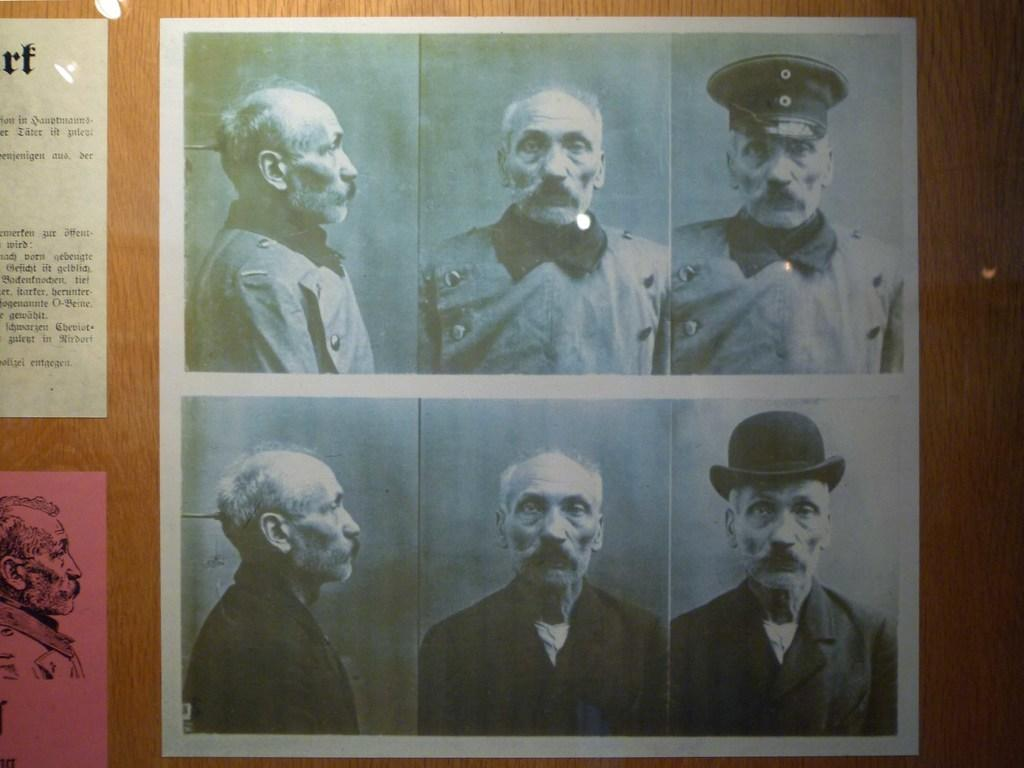Where was the image taken? The image is taken indoors. What can be seen on the wall in the image? There is a wall with a few posts in the image. What is on the poster in the image? There is text and images on the poster in the image. How many cattle can be seen crossing the river in the image? There are no cattle or rivers present in the image. 